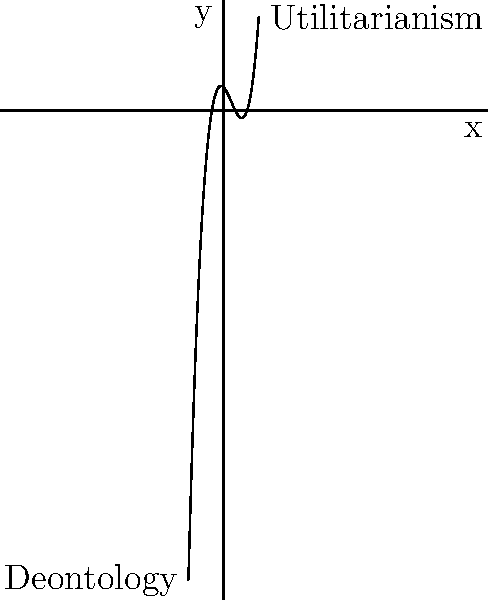In the given polynomial graph, the end behavior represents two contrasting philosophical theories: Utilitarianism and Deontology. Analyze the graph and explain how the polynomial's end behavior might symbolize the long-term implications of these theories. Which theory appears to have a more positive long-term outcome based on the graph, and why? To analyze this graph and its philosophical implications, let's follow these steps:

1. Observe the end behavior:
   - As $x$ approaches positive infinity, $y$ increases rapidly (Utilitarianism).
   - As $x$ approaches negative infinity, $y$ decreases rapidly (Deontology).

2. Interpret the end behavior:
   - The upward trend for Utilitarianism suggests increasingly positive outcomes over time.
   - The downward trend for Deontology implies potentially negative consequences in the long run.

3. Consider the theories:
   - Utilitarianism focuses on maximizing overall happiness or well-being for the greatest number of people.
   - Deontology emphasizes adherence to moral rules or duties, regardless of consequences.

4. Analyze long-term implications:
   - Utilitarianism's upward trend might represent the cumulative positive effects of actions aimed at maximizing overall well-being.
   - Deontology's downward trend could symbolize potential negative consequences of strict rule-following without considering outcomes.

5. Evaluate based on the graph:
   - Utilitarianism appears to have a more positive long-term outcome, as indicated by the upward trajectory.
   - This suggests that actions focused on maximizing overall happiness may lead to better results over time.

6. Consider limitations:
   - Remember that this is a simplified representation and real-world ethical situations are often more complex.
   - The graph doesn't account for potential short-term challenges in implementing utilitarian principles or the stability offered by deontological approaches.

Based on this analysis, the graph suggests that Utilitarianism may have more positive long-term implications, as represented by the upward trend in the polynomial's end behavior.
Answer: Utilitarianism, due to its upward trend representing potentially increasing positive outcomes over time. 